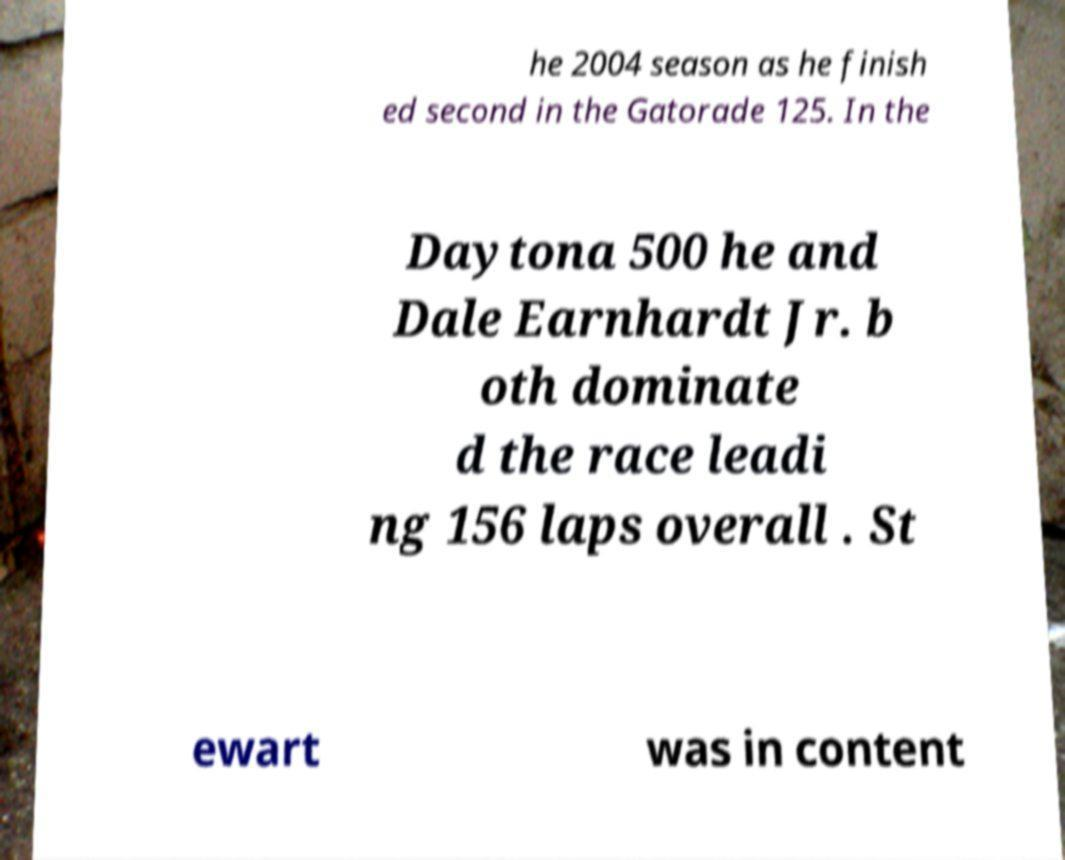Can you read and provide the text displayed in the image?This photo seems to have some interesting text. Can you extract and type it out for me? he 2004 season as he finish ed second in the Gatorade 125. In the Daytona 500 he and Dale Earnhardt Jr. b oth dominate d the race leadi ng 156 laps overall . St ewart was in content 